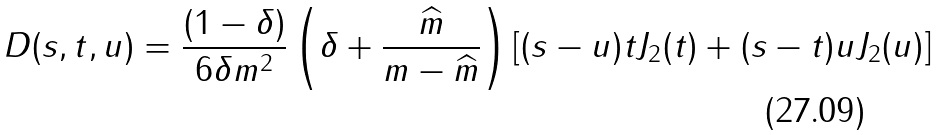Convert formula to latex. <formula><loc_0><loc_0><loc_500><loc_500>D ( s , t , u ) = \frac { ( 1 - \delta ) } { 6 \delta m ^ { 2 } } \left ( \delta + \frac { \widehat { m } } { m - \widehat { m } } \right ) [ ( s - u ) t J _ { 2 } ( t ) + ( s - t ) u J _ { 2 } ( u ) ]</formula> 